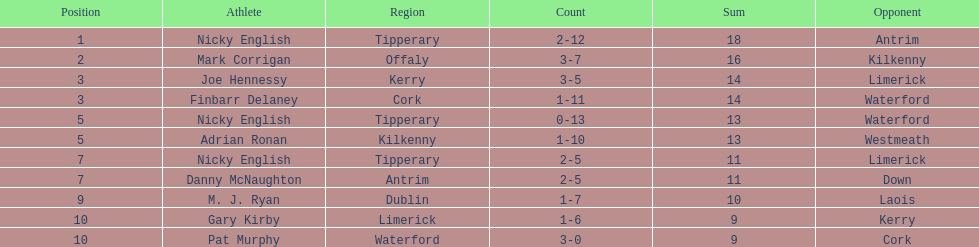If you added all the total's up, what would the number be? 138. 